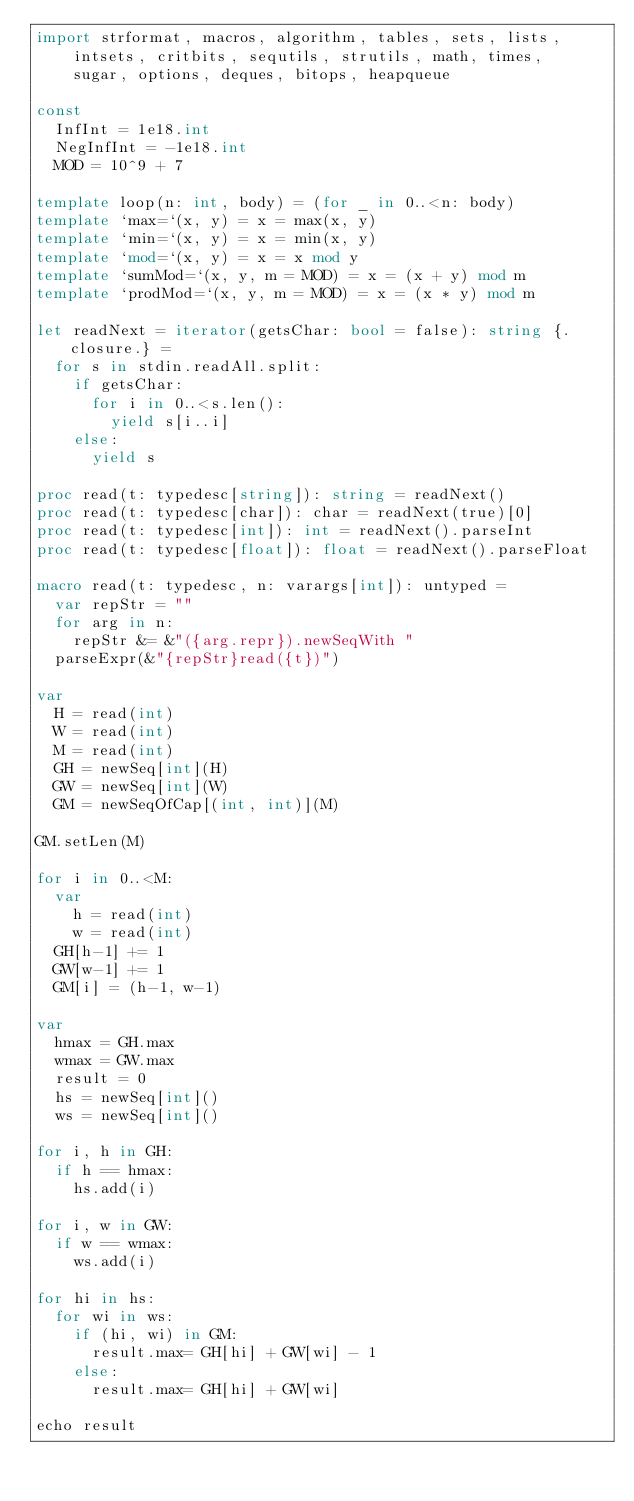<code> <loc_0><loc_0><loc_500><loc_500><_Nim_>import strformat, macros, algorithm, tables, sets, lists,
    intsets, critbits, sequtils, strutils, math, times,
    sugar, options, deques, bitops, heapqueue

const
  InfInt = 1e18.int
  NegInfInt = -1e18.int
  MOD = 10^9 + 7

template loop(n: int, body) = (for _ in 0..<n: body)
template `max=`(x, y) = x = max(x, y)
template `min=`(x, y) = x = min(x, y)
template `mod=`(x, y) = x = x mod y
template `sumMod=`(x, y, m = MOD) = x = (x + y) mod m
template `prodMod=`(x, y, m = MOD) = x = (x * y) mod m

let readNext = iterator(getsChar: bool = false): string {.closure.} =
  for s in stdin.readAll.split:
    if getsChar:
      for i in 0..<s.len():
        yield s[i..i]
    else:
      yield s

proc read(t: typedesc[string]): string = readNext()
proc read(t: typedesc[char]): char = readNext(true)[0]
proc read(t: typedesc[int]): int = readNext().parseInt
proc read(t: typedesc[float]): float = readNext().parseFloat

macro read(t: typedesc, n: varargs[int]): untyped =
  var repStr = ""
  for arg in n:
    repStr &= &"({arg.repr}).newSeqWith "
  parseExpr(&"{repStr}read({t})")

var
  H = read(int)
  W = read(int)
  M = read(int)
  GH = newSeq[int](H)
  GW = newSeq[int](W)
  GM = newSeqOfCap[(int, int)](M)

GM.setLen(M)

for i in 0..<M:
  var
    h = read(int)
    w = read(int)
  GH[h-1] += 1
  GW[w-1] += 1
  GM[i] = (h-1, w-1)

var
  hmax = GH.max
  wmax = GW.max
  result = 0
  hs = newSeq[int]()
  ws = newSeq[int]()

for i, h in GH:
  if h == hmax:
    hs.add(i)

for i, w in GW:
  if w == wmax:
    ws.add(i)

for hi in hs:
  for wi in ws:
    if (hi, wi) in GM:
      result.max= GH[hi] + GW[wi] - 1
    else:
      result.max= GH[hi] + GW[wi]

echo result
</code> 